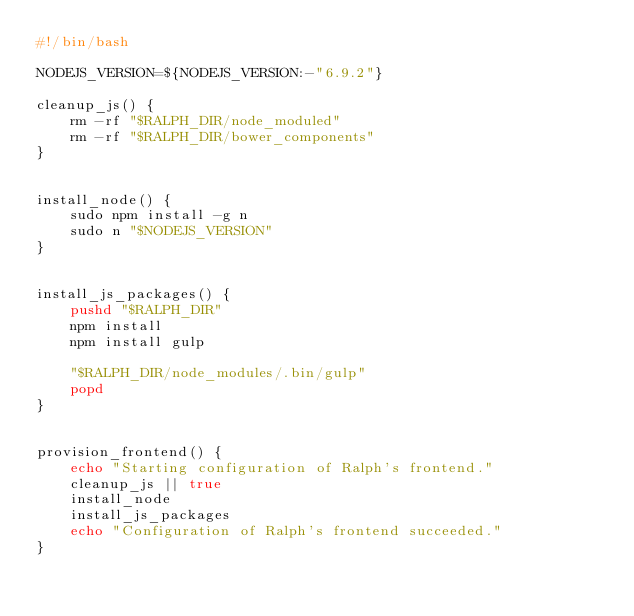<code> <loc_0><loc_0><loc_500><loc_500><_Bash_>#!/bin/bash

NODEJS_VERSION=${NODEJS_VERSION:-"6.9.2"}

cleanup_js() {
    rm -rf "$RALPH_DIR/node_moduled"
    rm -rf "$RALPH_DIR/bower_components"
}


install_node() {
    sudo npm install -g n
    sudo n "$NODEJS_VERSION"
}


install_js_packages() {
    pushd "$RALPH_DIR"
    npm install
    npm install gulp

    "$RALPH_DIR/node_modules/.bin/gulp"
    popd
}


provision_frontend() {
    echo "Starting configuration of Ralph's frontend."
    cleanup_js || true
    install_node
    install_js_packages
    echo "Configuration of Ralph's frontend succeeded."
}
</code> 